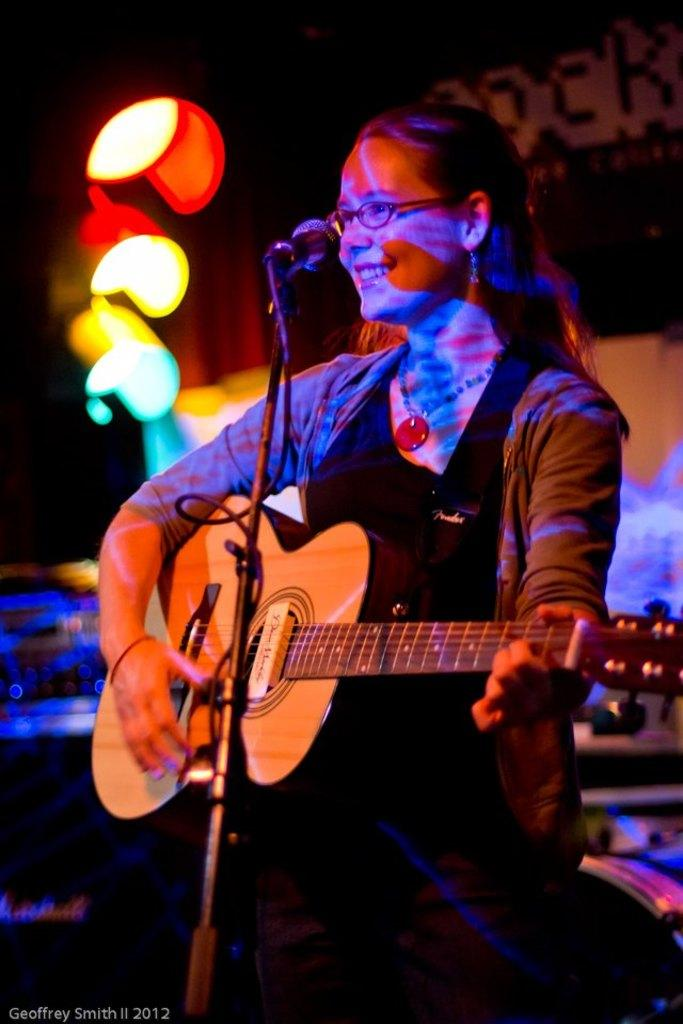Who is the main subject in the image? There is a woman in the image. What is the woman wearing? The woman is wearing a black dress. What is the woman doing in the image? The woman is playing a guitar. What object is in front of the woman? There is a microphone in front of the woman. What can be seen behind the woman? There are color lights visible behind the woman. How many birds are flying around the woman in the image? There are no birds visible in the image. What type of group is the woman a part of in the image? The image does not provide information about any group the woman might be a part of. 